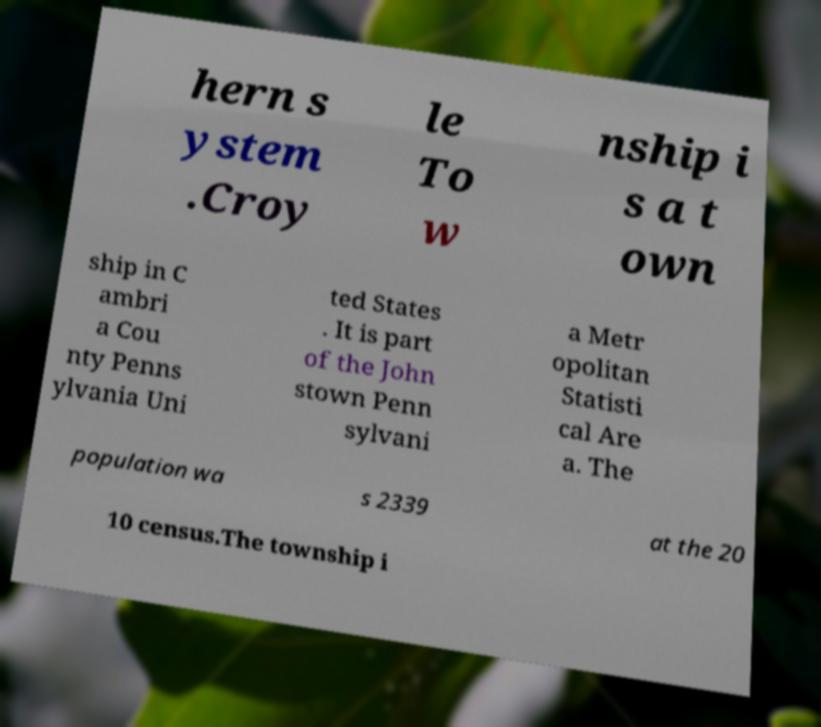Please read and relay the text visible in this image. What does it say? hern s ystem .Croy le To w nship i s a t own ship in C ambri a Cou nty Penns ylvania Uni ted States . It is part of the John stown Penn sylvani a Metr opolitan Statisti cal Are a. The population wa s 2339 at the 20 10 census.The township i 